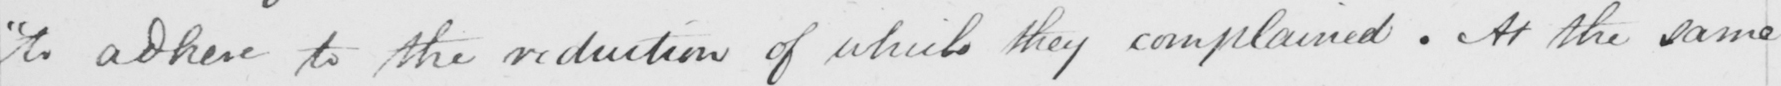Please transcribe the handwritten text in this image. " to adhere to the reduction of which they complained . At the same 